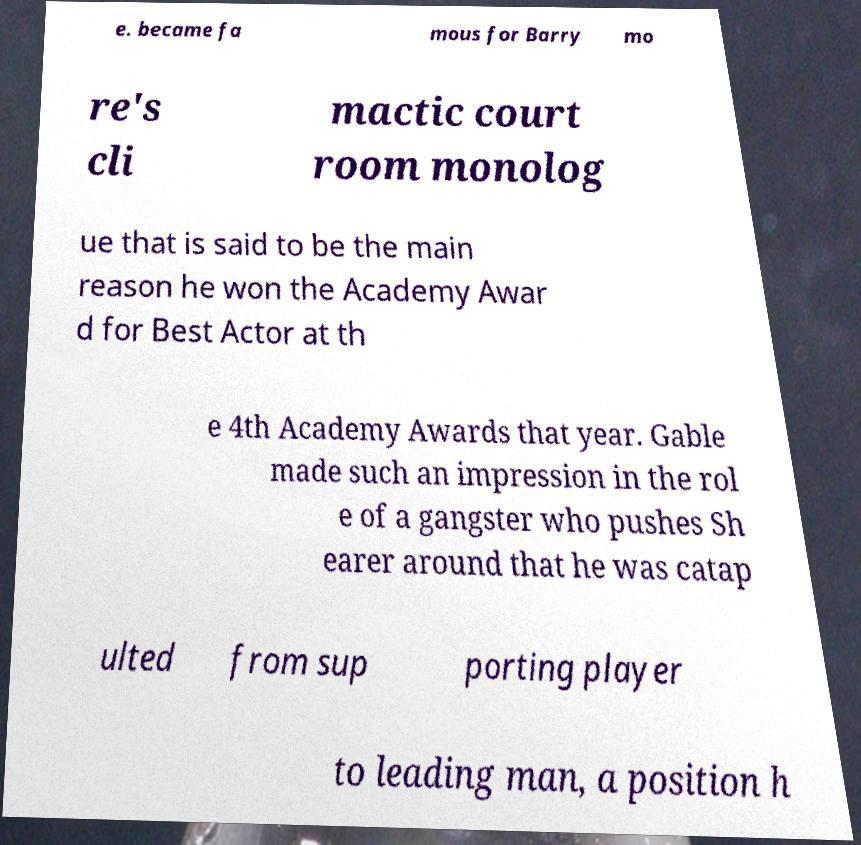Please read and relay the text visible in this image. What does it say? e. became fa mous for Barry mo re's cli mactic court room monolog ue that is said to be the main reason he won the Academy Awar d for Best Actor at th e 4th Academy Awards that year. Gable made such an impression in the rol e of a gangster who pushes Sh earer around that he was catap ulted from sup porting player to leading man, a position h 